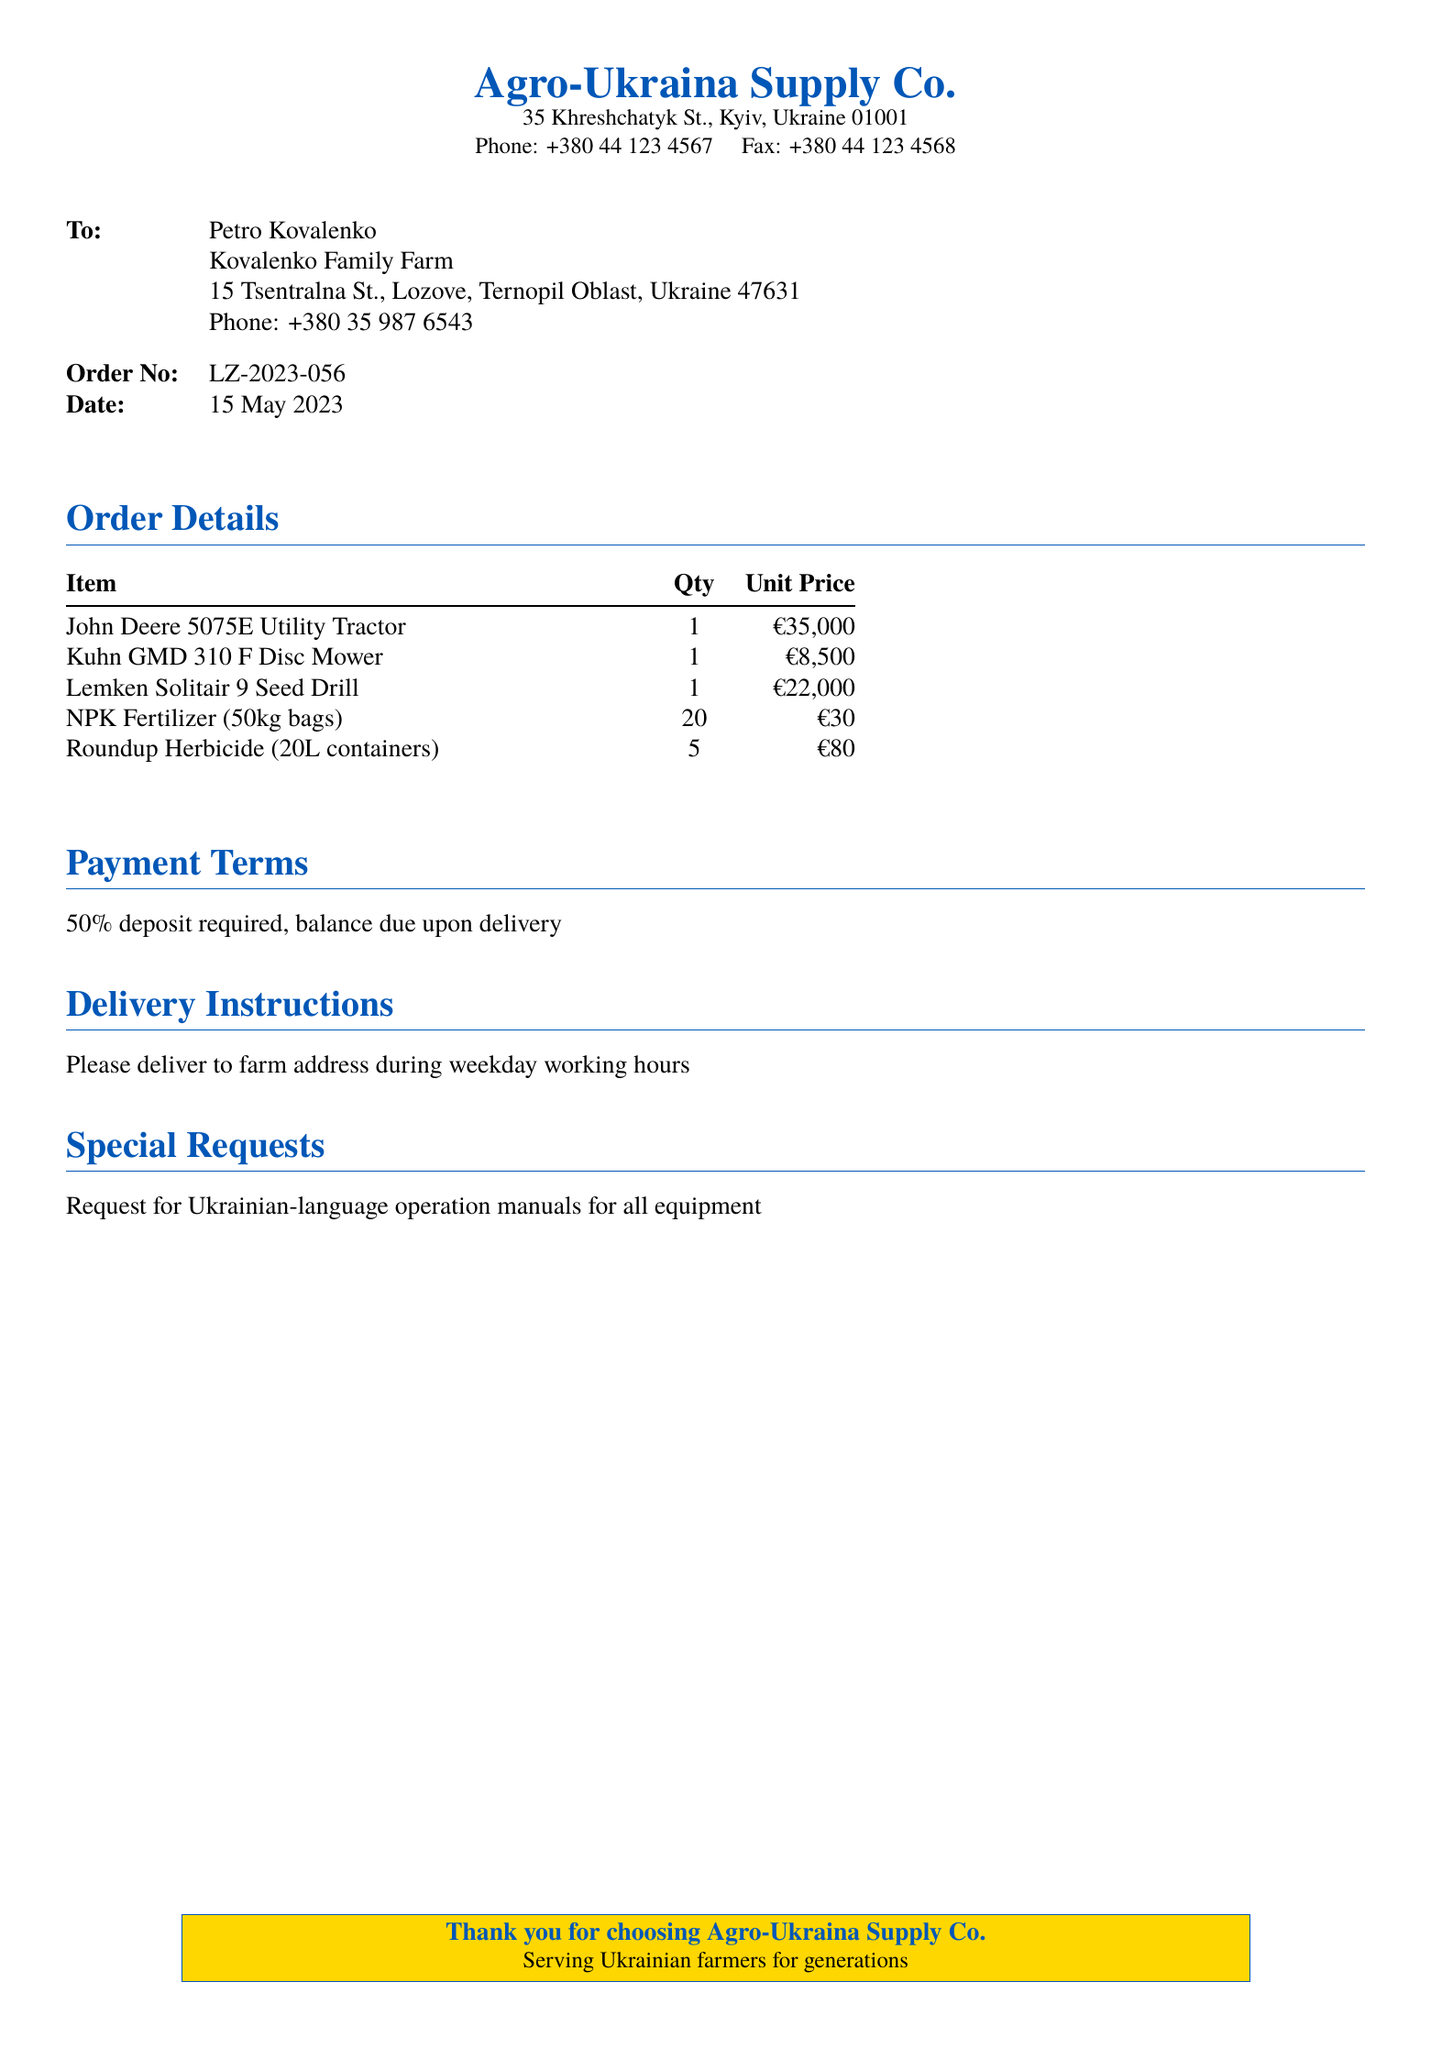What is the name of the supplier? The document identifies the supplier as Agro-Ukraina Supply Co.
Answer: Agro-Ukraina Supply Co What is the order number? The order number listed in the document is LZ-2023-056.
Answer: LZ-2023-056 What is the date of the order? The order was placed on 15 May 2023.
Answer: 15 May 2023 How many Kuhn GMD 310 F Disc Mowers were ordered? The document states that one Kuhn GMD 310 F Disc Mower was ordered.
Answer: 1 What is the total quantity of NPK Fertilizer ordered? The document lists a total of 20 bags of NPK Fertilizer.
Answer: 20 What payment is required upon delivery? The payment terms specify that the balance is due upon delivery.
Answer: Balance due upon delivery What special request was made in the document? The document contains a request for Ukrainian-language operation manuals.
Answer: Ukrainian-language operation manuals What is the total cost of the John Deere 5075E Utility Tractor? The unit price of the John Deere 5075E Utility Tractor is €35,000.
Answer: €35,000 When should the delivery be made? The delivery instructions indicate it should be made during weekday working hours.
Answer: Weekday working hours 